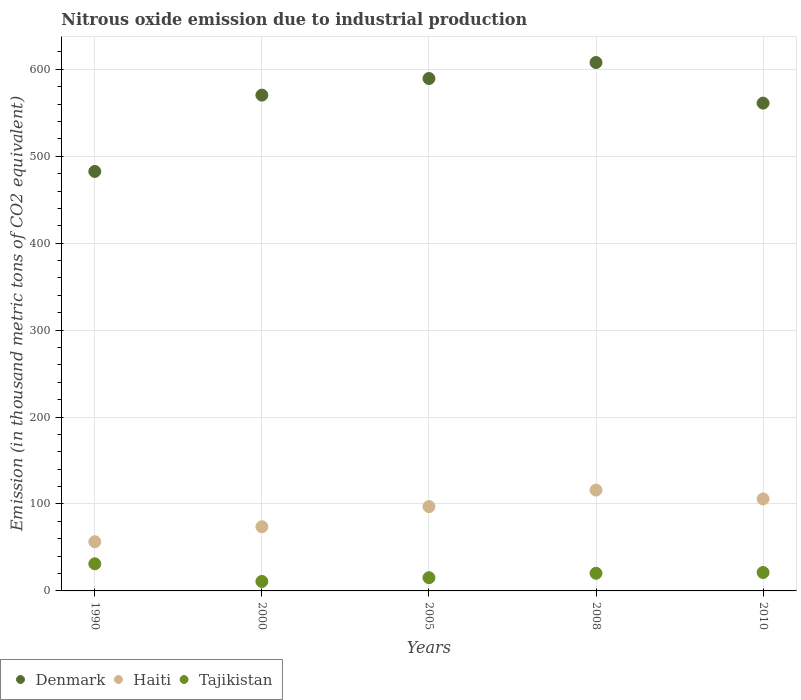Is the number of dotlines equal to the number of legend labels?
Keep it short and to the point. Yes. What is the amount of nitrous oxide emitted in Haiti in 2000?
Ensure brevity in your answer.  73.8. Across all years, what is the maximum amount of nitrous oxide emitted in Tajikistan?
Your response must be concise. 31.2. Across all years, what is the minimum amount of nitrous oxide emitted in Haiti?
Give a very brief answer. 56.6. What is the total amount of nitrous oxide emitted in Denmark in the graph?
Make the answer very short. 2811.1. What is the difference between the amount of nitrous oxide emitted in Denmark in 2008 and the amount of nitrous oxide emitted in Haiti in 2010?
Make the answer very short. 502. What is the average amount of nitrous oxide emitted in Denmark per year?
Your answer should be compact. 562.22. In the year 2008, what is the difference between the amount of nitrous oxide emitted in Denmark and amount of nitrous oxide emitted in Haiti?
Your response must be concise. 491.8. In how many years, is the amount of nitrous oxide emitted in Haiti greater than 440 thousand metric tons?
Ensure brevity in your answer.  0. What is the ratio of the amount of nitrous oxide emitted in Tajikistan in 2000 to that in 2010?
Your response must be concise. 0.51. Is the difference between the amount of nitrous oxide emitted in Denmark in 2008 and 2010 greater than the difference between the amount of nitrous oxide emitted in Haiti in 2008 and 2010?
Your response must be concise. Yes. What is the difference between the highest and the second highest amount of nitrous oxide emitted in Denmark?
Provide a succinct answer. 18.4. What is the difference between the highest and the lowest amount of nitrous oxide emitted in Tajikistan?
Provide a short and direct response. 20.3. Does the amount of nitrous oxide emitted in Denmark monotonically increase over the years?
Make the answer very short. No. How many years are there in the graph?
Your response must be concise. 5. What is the difference between two consecutive major ticks on the Y-axis?
Your response must be concise. 100. Are the values on the major ticks of Y-axis written in scientific E-notation?
Offer a terse response. No. Does the graph contain any zero values?
Make the answer very short. No. Does the graph contain grids?
Make the answer very short. Yes. Where does the legend appear in the graph?
Give a very brief answer. Bottom left. What is the title of the graph?
Your answer should be very brief. Nitrous oxide emission due to industrial production. What is the label or title of the X-axis?
Your answer should be compact. Years. What is the label or title of the Y-axis?
Make the answer very short. Emission (in thousand metric tons of CO2 equivalent). What is the Emission (in thousand metric tons of CO2 equivalent) of Denmark in 1990?
Your answer should be compact. 482.5. What is the Emission (in thousand metric tons of CO2 equivalent) in Haiti in 1990?
Offer a terse response. 56.6. What is the Emission (in thousand metric tons of CO2 equivalent) of Tajikistan in 1990?
Your answer should be very brief. 31.2. What is the Emission (in thousand metric tons of CO2 equivalent) of Denmark in 2000?
Your answer should be compact. 570.3. What is the Emission (in thousand metric tons of CO2 equivalent) of Haiti in 2000?
Provide a short and direct response. 73.8. What is the Emission (in thousand metric tons of CO2 equivalent) of Tajikistan in 2000?
Provide a short and direct response. 10.9. What is the Emission (in thousand metric tons of CO2 equivalent) of Denmark in 2005?
Offer a very short reply. 589.4. What is the Emission (in thousand metric tons of CO2 equivalent) of Haiti in 2005?
Offer a terse response. 97. What is the Emission (in thousand metric tons of CO2 equivalent) in Tajikistan in 2005?
Make the answer very short. 15.2. What is the Emission (in thousand metric tons of CO2 equivalent) of Denmark in 2008?
Offer a very short reply. 607.8. What is the Emission (in thousand metric tons of CO2 equivalent) of Haiti in 2008?
Make the answer very short. 116. What is the Emission (in thousand metric tons of CO2 equivalent) of Tajikistan in 2008?
Your answer should be very brief. 20.3. What is the Emission (in thousand metric tons of CO2 equivalent) of Denmark in 2010?
Offer a very short reply. 561.1. What is the Emission (in thousand metric tons of CO2 equivalent) of Haiti in 2010?
Provide a succinct answer. 105.8. What is the Emission (in thousand metric tons of CO2 equivalent) of Tajikistan in 2010?
Offer a very short reply. 21.2. Across all years, what is the maximum Emission (in thousand metric tons of CO2 equivalent) of Denmark?
Make the answer very short. 607.8. Across all years, what is the maximum Emission (in thousand metric tons of CO2 equivalent) in Haiti?
Your answer should be very brief. 116. Across all years, what is the maximum Emission (in thousand metric tons of CO2 equivalent) of Tajikistan?
Keep it short and to the point. 31.2. Across all years, what is the minimum Emission (in thousand metric tons of CO2 equivalent) in Denmark?
Offer a very short reply. 482.5. Across all years, what is the minimum Emission (in thousand metric tons of CO2 equivalent) of Haiti?
Ensure brevity in your answer.  56.6. What is the total Emission (in thousand metric tons of CO2 equivalent) in Denmark in the graph?
Your answer should be very brief. 2811.1. What is the total Emission (in thousand metric tons of CO2 equivalent) in Haiti in the graph?
Your answer should be very brief. 449.2. What is the total Emission (in thousand metric tons of CO2 equivalent) in Tajikistan in the graph?
Your response must be concise. 98.8. What is the difference between the Emission (in thousand metric tons of CO2 equivalent) of Denmark in 1990 and that in 2000?
Your response must be concise. -87.8. What is the difference between the Emission (in thousand metric tons of CO2 equivalent) of Haiti in 1990 and that in 2000?
Give a very brief answer. -17.2. What is the difference between the Emission (in thousand metric tons of CO2 equivalent) of Tajikistan in 1990 and that in 2000?
Your answer should be compact. 20.3. What is the difference between the Emission (in thousand metric tons of CO2 equivalent) of Denmark in 1990 and that in 2005?
Provide a succinct answer. -106.9. What is the difference between the Emission (in thousand metric tons of CO2 equivalent) in Haiti in 1990 and that in 2005?
Your answer should be compact. -40.4. What is the difference between the Emission (in thousand metric tons of CO2 equivalent) in Tajikistan in 1990 and that in 2005?
Provide a short and direct response. 16. What is the difference between the Emission (in thousand metric tons of CO2 equivalent) of Denmark in 1990 and that in 2008?
Ensure brevity in your answer.  -125.3. What is the difference between the Emission (in thousand metric tons of CO2 equivalent) of Haiti in 1990 and that in 2008?
Provide a short and direct response. -59.4. What is the difference between the Emission (in thousand metric tons of CO2 equivalent) of Tajikistan in 1990 and that in 2008?
Give a very brief answer. 10.9. What is the difference between the Emission (in thousand metric tons of CO2 equivalent) of Denmark in 1990 and that in 2010?
Your answer should be compact. -78.6. What is the difference between the Emission (in thousand metric tons of CO2 equivalent) in Haiti in 1990 and that in 2010?
Offer a terse response. -49.2. What is the difference between the Emission (in thousand metric tons of CO2 equivalent) in Denmark in 2000 and that in 2005?
Provide a succinct answer. -19.1. What is the difference between the Emission (in thousand metric tons of CO2 equivalent) of Haiti in 2000 and that in 2005?
Ensure brevity in your answer.  -23.2. What is the difference between the Emission (in thousand metric tons of CO2 equivalent) of Denmark in 2000 and that in 2008?
Your answer should be very brief. -37.5. What is the difference between the Emission (in thousand metric tons of CO2 equivalent) in Haiti in 2000 and that in 2008?
Offer a terse response. -42.2. What is the difference between the Emission (in thousand metric tons of CO2 equivalent) in Tajikistan in 2000 and that in 2008?
Ensure brevity in your answer.  -9.4. What is the difference between the Emission (in thousand metric tons of CO2 equivalent) of Haiti in 2000 and that in 2010?
Give a very brief answer. -32. What is the difference between the Emission (in thousand metric tons of CO2 equivalent) of Tajikistan in 2000 and that in 2010?
Give a very brief answer. -10.3. What is the difference between the Emission (in thousand metric tons of CO2 equivalent) of Denmark in 2005 and that in 2008?
Offer a very short reply. -18.4. What is the difference between the Emission (in thousand metric tons of CO2 equivalent) in Denmark in 2005 and that in 2010?
Give a very brief answer. 28.3. What is the difference between the Emission (in thousand metric tons of CO2 equivalent) in Haiti in 2005 and that in 2010?
Provide a succinct answer. -8.8. What is the difference between the Emission (in thousand metric tons of CO2 equivalent) in Denmark in 2008 and that in 2010?
Offer a very short reply. 46.7. What is the difference between the Emission (in thousand metric tons of CO2 equivalent) of Denmark in 1990 and the Emission (in thousand metric tons of CO2 equivalent) of Haiti in 2000?
Make the answer very short. 408.7. What is the difference between the Emission (in thousand metric tons of CO2 equivalent) in Denmark in 1990 and the Emission (in thousand metric tons of CO2 equivalent) in Tajikistan in 2000?
Ensure brevity in your answer.  471.6. What is the difference between the Emission (in thousand metric tons of CO2 equivalent) of Haiti in 1990 and the Emission (in thousand metric tons of CO2 equivalent) of Tajikistan in 2000?
Your answer should be compact. 45.7. What is the difference between the Emission (in thousand metric tons of CO2 equivalent) in Denmark in 1990 and the Emission (in thousand metric tons of CO2 equivalent) in Haiti in 2005?
Your answer should be compact. 385.5. What is the difference between the Emission (in thousand metric tons of CO2 equivalent) in Denmark in 1990 and the Emission (in thousand metric tons of CO2 equivalent) in Tajikistan in 2005?
Ensure brevity in your answer.  467.3. What is the difference between the Emission (in thousand metric tons of CO2 equivalent) of Haiti in 1990 and the Emission (in thousand metric tons of CO2 equivalent) of Tajikistan in 2005?
Offer a very short reply. 41.4. What is the difference between the Emission (in thousand metric tons of CO2 equivalent) in Denmark in 1990 and the Emission (in thousand metric tons of CO2 equivalent) in Haiti in 2008?
Offer a very short reply. 366.5. What is the difference between the Emission (in thousand metric tons of CO2 equivalent) of Denmark in 1990 and the Emission (in thousand metric tons of CO2 equivalent) of Tajikistan in 2008?
Your answer should be compact. 462.2. What is the difference between the Emission (in thousand metric tons of CO2 equivalent) of Haiti in 1990 and the Emission (in thousand metric tons of CO2 equivalent) of Tajikistan in 2008?
Your response must be concise. 36.3. What is the difference between the Emission (in thousand metric tons of CO2 equivalent) of Denmark in 1990 and the Emission (in thousand metric tons of CO2 equivalent) of Haiti in 2010?
Keep it short and to the point. 376.7. What is the difference between the Emission (in thousand metric tons of CO2 equivalent) in Denmark in 1990 and the Emission (in thousand metric tons of CO2 equivalent) in Tajikistan in 2010?
Ensure brevity in your answer.  461.3. What is the difference between the Emission (in thousand metric tons of CO2 equivalent) of Haiti in 1990 and the Emission (in thousand metric tons of CO2 equivalent) of Tajikistan in 2010?
Offer a terse response. 35.4. What is the difference between the Emission (in thousand metric tons of CO2 equivalent) in Denmark in 2000 and the Emission (in thousand metric tons of CO2 equivalent) in Haiti in 2005?
Your answer should be very brief. 473.3. What is the difference between the Emission (in thousand metric tons of CO2 equivalent) of Denmark in 2000 and the Emission (in thousand metric tons of CO2 equivalent) of Tajikistan in 2005?
Make the answer very short. 555.1. What is the difference between the Emission (in thousand metric tons of CO2 equivalent) of Haiti in 2000 and the Emission (in thousand metric tons of CO2 equivalent) of Tajikistan in 2005?
Offer a very short reply. 58.6. What is the difference between the Emission (in thousand metric tons of CO2 equivalent) in Denmark in 2000 and the Emission (in thousand metric tons of CO2 equivalent) in Haiti in 2008?
Provide a succinct answer. 454.3. What is the difference between the Emission (in thousand metric tons of CO2 equivalent) of Denmark in 2000 and the Emission (in thousand metric tons of CO2 equivalent) of Tajikistan in 2008?
Provide a succinct answer. 550. What is the difference between the Emission (in thousand metric tons of CO2 equivalent) of Haiti in 2000 and the Emission (in thousand metric tons of CO2 equivalent) of Tajikistan in 2008?
Provide a short and direct response. 53.5. What is the difference between the Emission (in thousand metric tons of CO2 equivalent) in Denmark in 2000 and the Emission (in thousand metric tons of CO2 equivalent) in Haiti in 2010?
Keep it short and to the point. 464.5. What is the difference between the Emission (in thousand metric tons of CO2 equivalent) in Denmark in 2000 and the Emission (in thousand metric tons of CO2 equivalent) in Tajikistan in 2010?
Your response must be concise. 549.1. What is the difference between the Emission (in thousand metric tons of CO2 equivalent) in Haiti in 2000 and the Emission (in thousand metric tons of CO2 equivalent) in Tajikistan in 2010?
Give a very brief answer. 52.6. What is the difference between the Emission (in thousand metric tons of CO2 equivalent) in Denmark in 2005 and the Emission (in thousand metric tons of CO2 equivalent) in Haiti in 2008?
Make the answer very short. 473.4. What is the difference between the Emission (in thousand metric tons of CO2 equivalent) in Denmark in 2005 and the Emission (in thousand metric tons of CO2 equivalent) in Tajikistan in 2008?
Your answer should be compact. 569.1. What is the difference between the Emission (in thousand metric tons of CO2 equivalent) in Haiti in 2005 and the Emission (in thousand metric tons of CO2 equivalent) in Tajikistan in 2008?
Your answer should be very brief. 76.7. What is the difference between the Emission (in thousand metric tons of CO2 equivalent) in Denmark in 2005 and the Emission (in thousand metric tons of CO2 equivalent) in Haiti in 2010?
Your answer should be compact. 483.6. What is the difference between the Emission (in thousand metric tons of CO2 equivalent) in Denmark in 2005 and the Emission (in thousand metric tons of CO2 equivalent) in Tajikistan in 2010?
Offer a very short reply. 568.2. What is the difference between the Emission (in thousand metric tons of CO2 equivalent) in Haiti in 2005 and the Emission (in thousand metric tons of CO2 equivalent) in Tajikistan in 2010?
Ensure brevity in your answer.  75.8. What is the difference between the Emission (in thousand metric tons of CO2 equivalent) in Denmark in 2008 and the Emission (in thousand metric tons of CO2 equivalent) in Haiti in 2010?
Your response must be concise. 502. What is the difference between the Emission (in thousand metric tons of CO2 equivalent) of Denmark in 2008 and the Emission (in thousand metric tons of CO2 equivalent) of Tajikistan in 2010?
Your answer should be compact. 586.6. What is the difference between the Emission (in thousand metric tons of CO2 equivalent) of Haiti in 2008 and the Emission (in thousand metric tons of CO2 equivalent) of Tajikistan in 2010?
Provide a succinct answer. 94.8. What is the average Emission (in thousand metric tons of CO2 equivalent) of Denmark per year?
Your response must be concise. 562.22. What is the average Emission (in thousand metric tons of CO2 equivalent) of Haiti per year?
Keep it short and to the point. 89.84. What is the average Emission (in thousand metric tons of CO2 equivalent) in Tajikistan per year?
Your answer should be very brief. 19.76. In the year 1990, what is the difference between the Emission (in thousand metric tons of CO2 equivalent) in Denmark and Emission (in thousand metric tons of CO2 equivalent) in Haiti?
Your answer should be very brief. 425.9. In the year 1990, what is the difference between the Emission (in thousand metric tons of CO2 equivalent) in Denmark and Emission (in thousand metric tons of CO2 equivalent) in Tajikistan?
Make the answer very short. 451.3. In the year 1990, what is the difference between the Emission (in thousand metric tons of CO2 equivalent) of Haiti and Emission (in thousand metric tons of CO2 equivalent) of Tajikistan?
Provide a short and direct response. 25.4. In the year 2000, what is the difference between the Emission (in thousand metric tons of CO2 equivalent) in Denmark and Emission (in thousand metric tons of CO2 equivalent) in Haiti?
Provide a succinct answer. 496.5. In the year 2000, what is the difference between the Emission (in thousand metric tons of CO2 equivalent) in Denmark and Emission (in thousand metric tons of CO2 equivalent) in Tajikistan?
Make the answer very short. 559.4. In the year 2000, what is the difference between the Emission (in thousand metric tons of CO2 equivalent) of Haiti and Emission (in thousand metric tons of CO2 equivalent) of Tajikistan?
Keep it short and to the point. 62.9. In the year 2005, what is the difference between the Emission (in thousand metric tons of CO2 equivalent) in Denmark and Emission (in thousand metric tons of CO2 equivalent) in Haiti?
Your response must be concise. 492.4. In the year 2005, what is the difference between the Emission (in thousand metric tons of CO2 equivalent) of Denmark and Emission (in thousand metric tons of CO2 equivalent) of Tajikistan?
Your response must be concise. 574.2. In the year 2005, what is the difference between the Emission (in thousand metric tons of CO2 equivalent) of Haiti and Emission (in thousand metric tons of CO2 equivalent) of Tajikistan?
Offer a terse response. 81.8. In the year 2008, what is the difference between the Emission (in thousand metric tons of CO2 equivalent) in Denmark and Emission (in thousand metric tons of CO2 equivalent) in Haiti?
Give a very brief answer. 491.8. In the year 2008, what is the difference between the Emission (in thousand metric tons of CO2 equivalent) of Denmark and Emission (in thousand metric tons of CO2 equivalent) of Tajikistan?
Provide a short and direct response. 587.5. In the year 2008, what is the difference between the Emission (in thousand metric tons of CO2 equivalent) of Haiti and Emission (in thousand metric tons of CO2 equivalent) of Tajikistan?
Give a very brief answer. 95.7. In the year 2010, what is the difference between the Emission (in thousand metric tons of CO2 equivalent) in Denmark and Emission (in thousand metric tons of CO2 equivalent) in Haiti?
Your response must be concise. 455.3. In the year 2010, what is the difference between the Emission (in thousand metric tons of CO2 equivalent) of Denmark and Emission (in thousand metric tons of CO2 equivalent) of Tajikistan?
Your response must be concise. 539.9. In the year 2010, what is the difference between the Emission (in thousand metric tons of CO2 equivalent) of Haiti and Emission (in thousand metric tons of CO2 equivalent) of Tajikistan?
Provide a short and direct response. 84.6. What is the ratio of the Emission (in thousand metric tons of CO2 equivalent) of Denmark in 1990 to that in 2000?
Provide a succinct answer. 0.85. What is the ratio of the Emission (in thousand metric tons of CO2 equivalent) in Haiti in 1990 to that in 2000?
Ensure brevity in your answer.  0.77. What is the ratio of the Emission (in thousand metric tons of CO2 equivalent) in Tajikistan in 1990 to that in 2000?
Offer a very short reply. 2.86. What is the ratio of the Emission (in thousand metric tons of CO2 equivalent) in Denmark in 1990 to that in 2005?
Provide a short and direct response. 0.82. What is the ratio of the Emission (in thousand metric tons of CO2 equivalent) in Haiti in 1990 to that in 2005?
Offer a very short reply. 0.58. What is the ratio of the Emission (in thousand metric tons of CO2 equivalent) of Tajikistan in 1990 to that in 2005?
Offer a terse response. 2.05. What is the ratio of the Emission (in thousand metric tons of CO2 equivalent) in Denmark in 1990 to that in 2008?
Ensure brevity in your answer.  0.79. What is the ratio of the Emission (in thousand metric tons of CO2 equivalent) in Haiti in 1990 to that in 2008?
Ensure brevity in your answer.  0.49. What is the ratio of the Emission (in thousand metric tons of CO2 equivalent) of Tajikistan in 1990 to that in 2008?
Your answer should be very brief. 1.54. What is the ratio of the Emission (in thousand metric tons of CO2 equivalent) of Denmark in 1990 to that in 2010?
Provide a short and direct response. 0.86. What is the ratio of the Emission (in thousand metric tons of CO2 equivalent) in Haiti in 1990 to that in 2010?
Offer a terse response. 0.54. What is the ratio of the Emission (in thousand metric tons of CO2 equivalent) in Tajikistan in 1990 to that in 2010?
Your response must be concise. 1.47. What is the ratio of the Emission (in thousand metric tons of CO2 equivalent) of Denmark in 2000 to that in 2005?
Ensure brevity in your answer.  0.97. What is the ratio of the Emission (in thousand metric tons of CO2 equivalent) in Haiti in 2000 to that in 2005?
Ensure brevity in your answer.  0.76. What is the ratio of the Emission (in thousand metric tons of CO2 equivalent) of Tajikistan in 2000 to that in 2005?
Provide a short and direct response. 0.72. What is the ratio of the Emission (in thousand metric tons of CO2 equivalent) in Denmark in 2000 to that in 2008?
Ensure brevity in your answer.  0.94. What is the ratio of the Emission (in thousand metric tons of CO2 equivalent) in Haiti in 2000 to that in 2008?
Provide a succinct answer. 0.64. What is the ratio of the Emission (in thousand metric tons of CO2 equivalent) in Tajikistan in 2000 to that in 2008?
Your response must be concise. 0.54. What is the ratio of the Emission (in thousand metric tons of CO2 equivalent) in Denmark in 2000 to that in 2010?
Provide a succinct answer. 1.02. What is the ratio of the Emission (in thousand metric tons of CO2 equivalent) in Haiti in 2000 to that in 2010?
Your answer should be compact. 0.7. What is the ratio of the Emission (in thousand metric tons of CO2 equivalent) of Tajikistan in 2000 to that in 2010?
Offer a terse response. 0.51. What is the ratio of the Emission (in thousand metric tons of CO2 equivalent) of Denmark in 2005 to that in 2008?
Make the answer very short. 0.97. What is the ratio of the Emission (in thousand metric tons of CO2 equivalent) in Haiti in 2005 to that in 2008?
Offer a terse response. 0.84. What is the ratio of the Emission (in thousand metric tons of CO2 equivalent) in Tajikistan in 2005 to that in 2008?
Offer a very short reply. 0.75. What is the ratio of the Emission (in thousand metric tons of CO2 equivalent) in Denmark in 2005 to that in 2010?
Make the answer very short. 1.05. What is the ratio of the Emission (in thousand metric tons of CO2 equivalent) in Haiti in 2005 to that in 2010?
Ensure brevity in your answer.  0.92. What is the ratio of the Emission (in thousand metric tons of CO2 equivalent) in Tajikistan in 2005 to that in 2010?
Provide a short and direct response. 0.72. What is the ratio of the Emission (in thousand metric tons of CO2 equivalent) of Denmark in 2008 to that in 2010?
Keep it short and to the point. 1.08. What is the ratio of the Emission (in thousand metric tons of CO2 equivalent) in Haiti in 2008 to that in 2010?
Your answer should be compact. 1.1. What is the ratio of the Emission (in thousand metric tons of CO2 equivalent) of Tajikistan in 2008 to that in 2010?
Your answer should be compact. 0.96. What is the difference between the highest and the second highest Emission (in thousand metric tons of CO2 equivalent) of Haiti?
Ensure brevity in your answer.  10.2. What is the difference between the highest and the lowest Emission (in thousand metric tons of CO2 equivalent) of Denmark?
Keep it short and to the point. 125.3. What is the difference between the highest and the lowest Emission (in thousand metric tons of CO2 equivalent) of Haiti?
Make the answer very short. 59.4. What is the difference between the highest and the lowest Emission (in thousand metric tons of CO2 equivalent) in Tajikistan?
Your response must be concise. 20.3. 